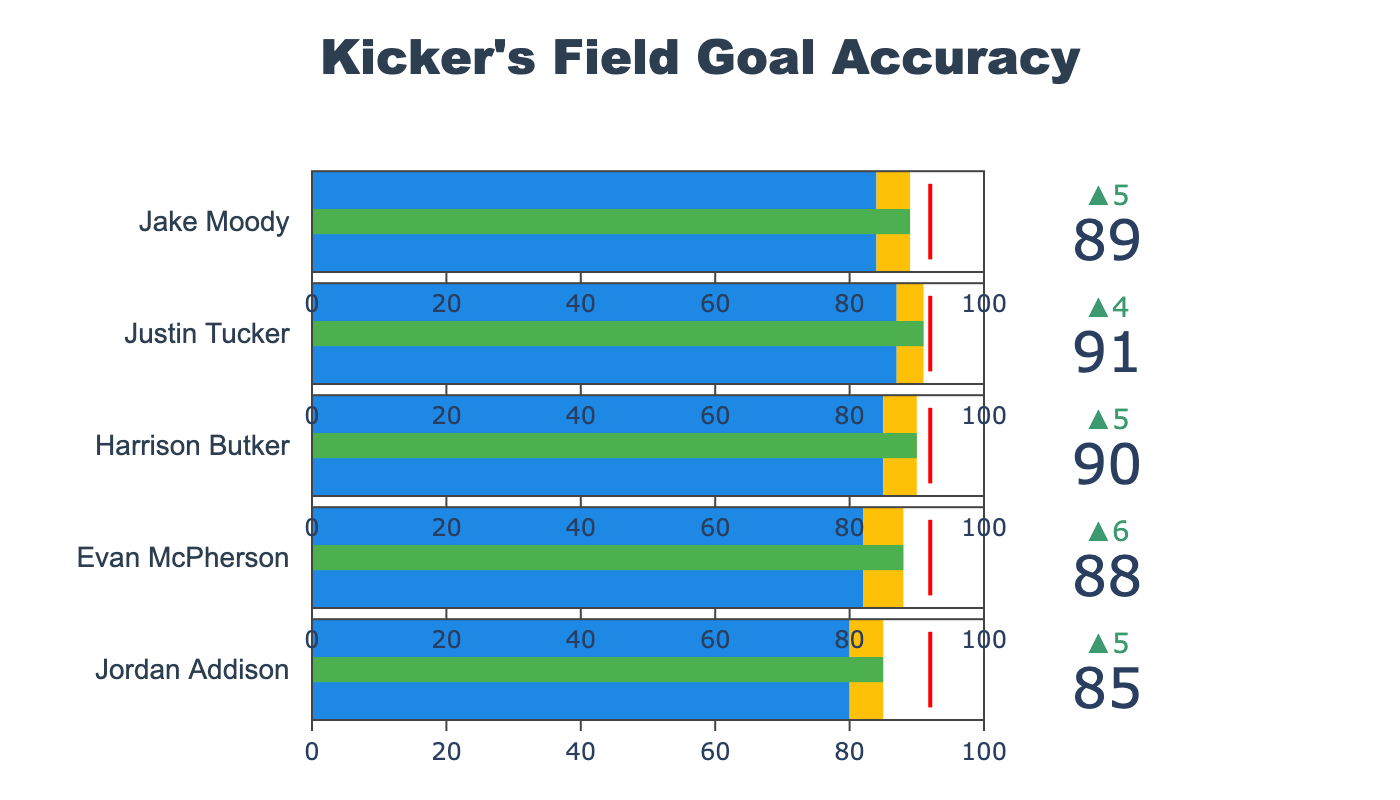Who is the NCAA leader in field goal accuracy? The red threshold line at the top of each bullet gauge indicates the NCAA leader's accuracy. All values for the NCAA leader are the same in this chart.
Answer: 92 What is the title of the figure? The title is prominently displayed at the top of the figure.
Answer: Kicker's Field Goal Accuracy How many kickers' field goal performances are displayed in the chart? The chart has one bullet gauge per kicker, and there are five gauges in total, each corresponding to a different kicker.
Answer: 5 Which kicker has the highest actual field goal accuracy? The highest value in the Actual column is assessed; "Justin Tucker" has the highest actual accuracy at 91.
Answer: Justin Tucker What is the difference between Jake Moody's actual and expected field goal accuracy? Jake Moody's actual accuracy is 89 and his expected accuracy is 84. Subtract the expected from the actual: 89 - 84.
Answer: 5 Who exceeded their expected performance by the largest margin? Compare the difference between the actual and expected values for each kicker. Justin Tucker's difference is the largest: 91 - 87 = 4.
Answer: Justin Tucker What is the average expected field goal accuracy for the five kickers? Sum up the expected values (80 + 82 + 85 + 87 + 84) and divide by the number of kickers (5). (80 + 82 + 85 + 87 + 84) / 5 = 418 / 5 = 83.6.
Answer: 83.6 How does Harrison Butker's actual performance compare to the NCAA leader? Harrison Butker's actual value is 90, which is less than the NCAA leader's 92.
Answer: Less than Which kicker has the smallest difference between their actual and expected performance? Calculate the differences: Jordan Addison (5), Evan McPherson (6), Harrison Butker (5), Justin Tucker (4), Jake Moody (5). The smallest difference is Justin Tucker's 4.
Answer: Justin Tucker 